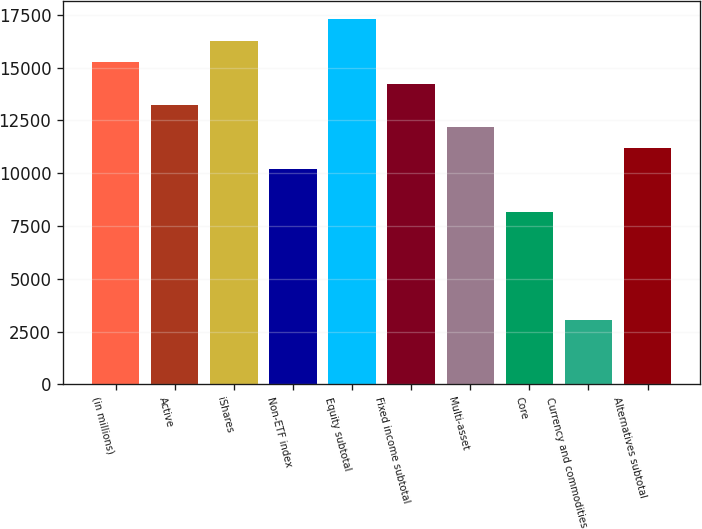Convert chart to OTSL. <chart><loc_0><loc_0><loc_500><loc_500><bar_chart><fcel>(in millions)<fcel>Active<fcel>iShares<fcel>Non-ETF index<fcel>Equity subtotal<fcel>Fixed income subtotal<fcel>Multi-asset<fcel>Core<fcel>Currency and commodities<fcel>Alternatives subtotal<nl><fcel>15257.5<fcel>13226.5<fcel>16273<fcel>10180<fcel>17288.5<fcel>14242<fcel>12211<fcel>8149<fcel>3071.5<fcel>11195.5<nl></chart> 